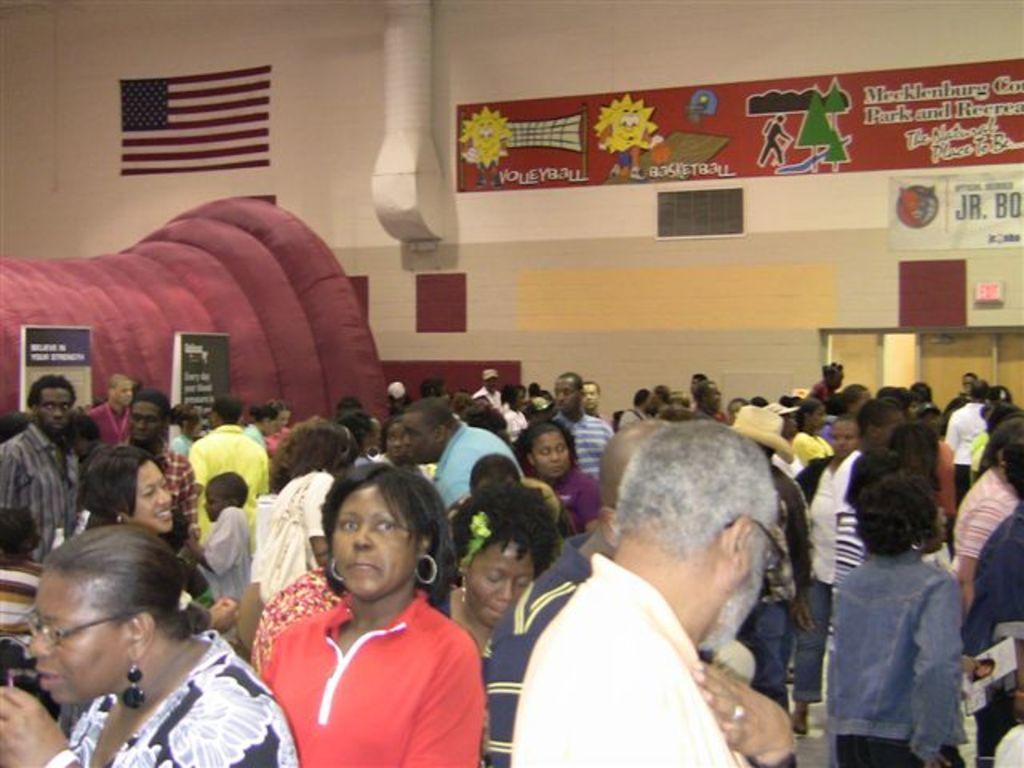In one or two sentences, can you explain what this image depicts? In this picture I can observe some people standing on the floor. There are men and women in this picture. On the left side I can observe flag on the wall. In the background there is a wall. 